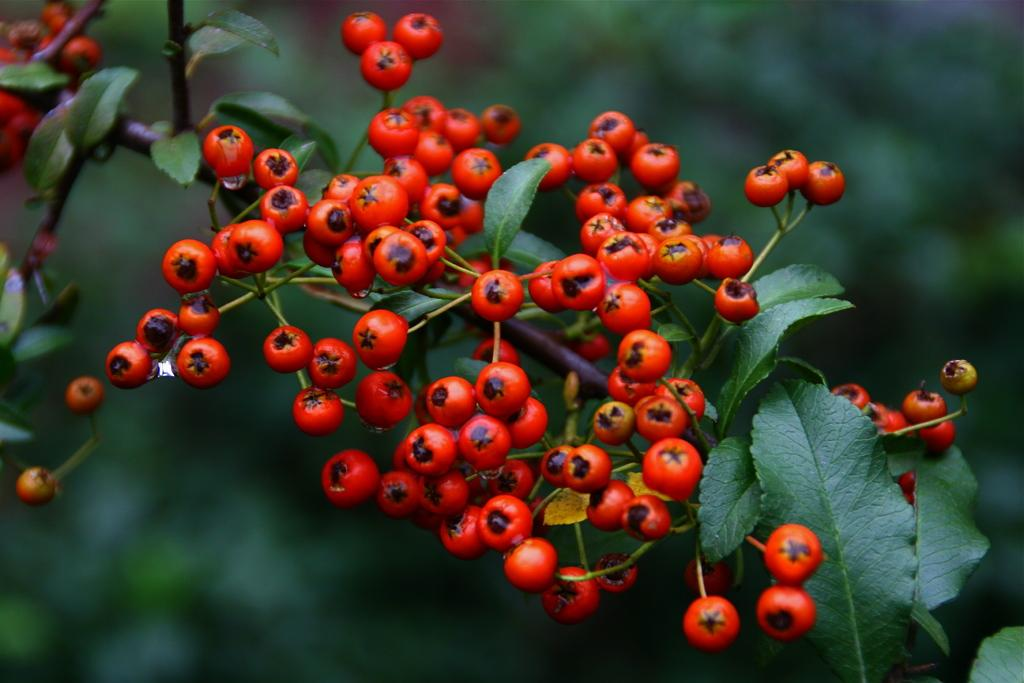What is the main object in the image? There is a tree in the image. What is special about the tree? The tree has fruits. What color is predominant in the background of the image? The background of the image is green. What type of poison can be seen on the leaves of the tree in the image? There is no poison present on the leaves of the tree in the image. 